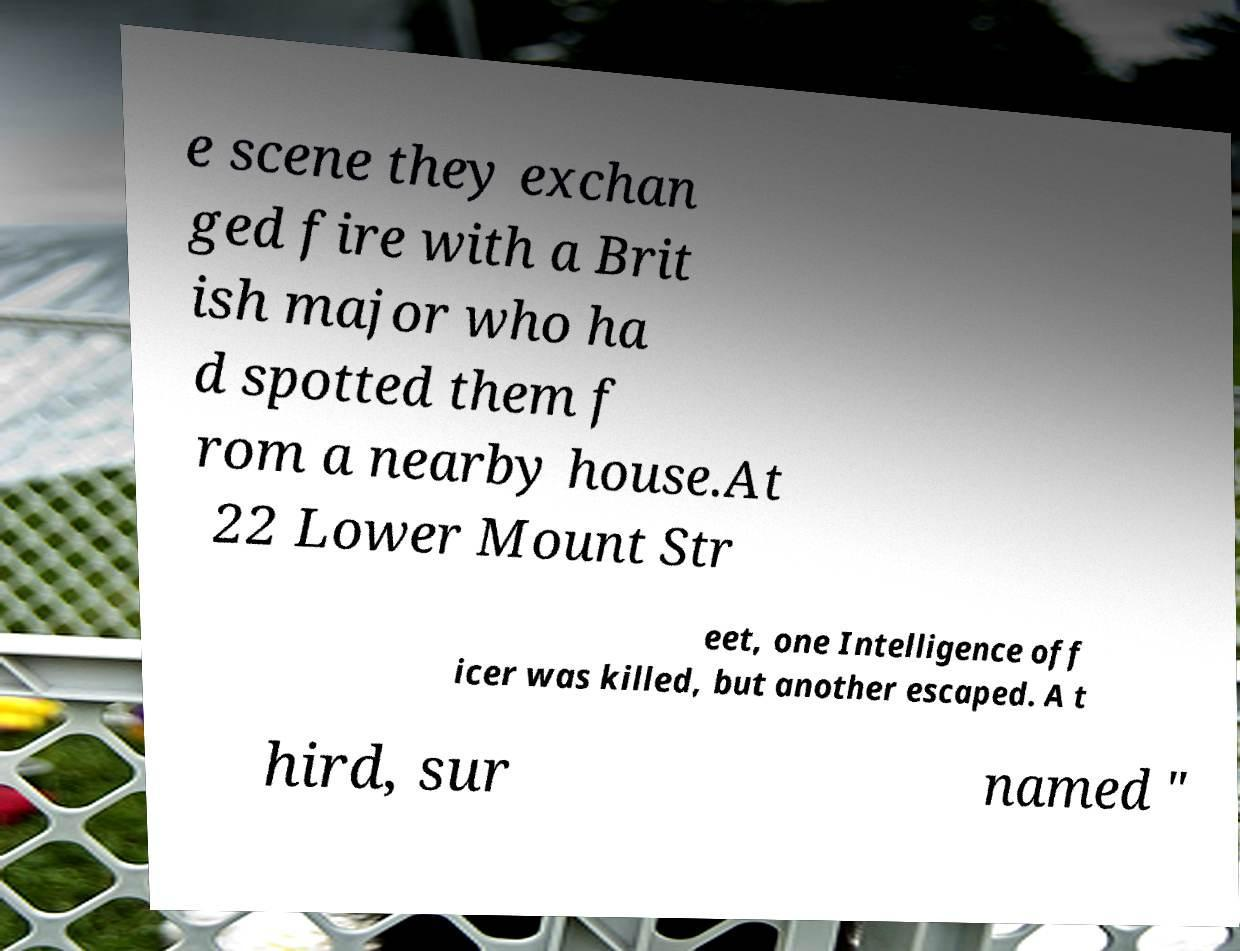I need the written content from this picture converted into text. Can you do that? e scene they exchan ged fire with a Brit ish major who ha d spotted them f rom a nearby house.At 22 Lower Mount Str eet, one Intelligence off icer was killed, but another escaped. A t hird, sur named " 